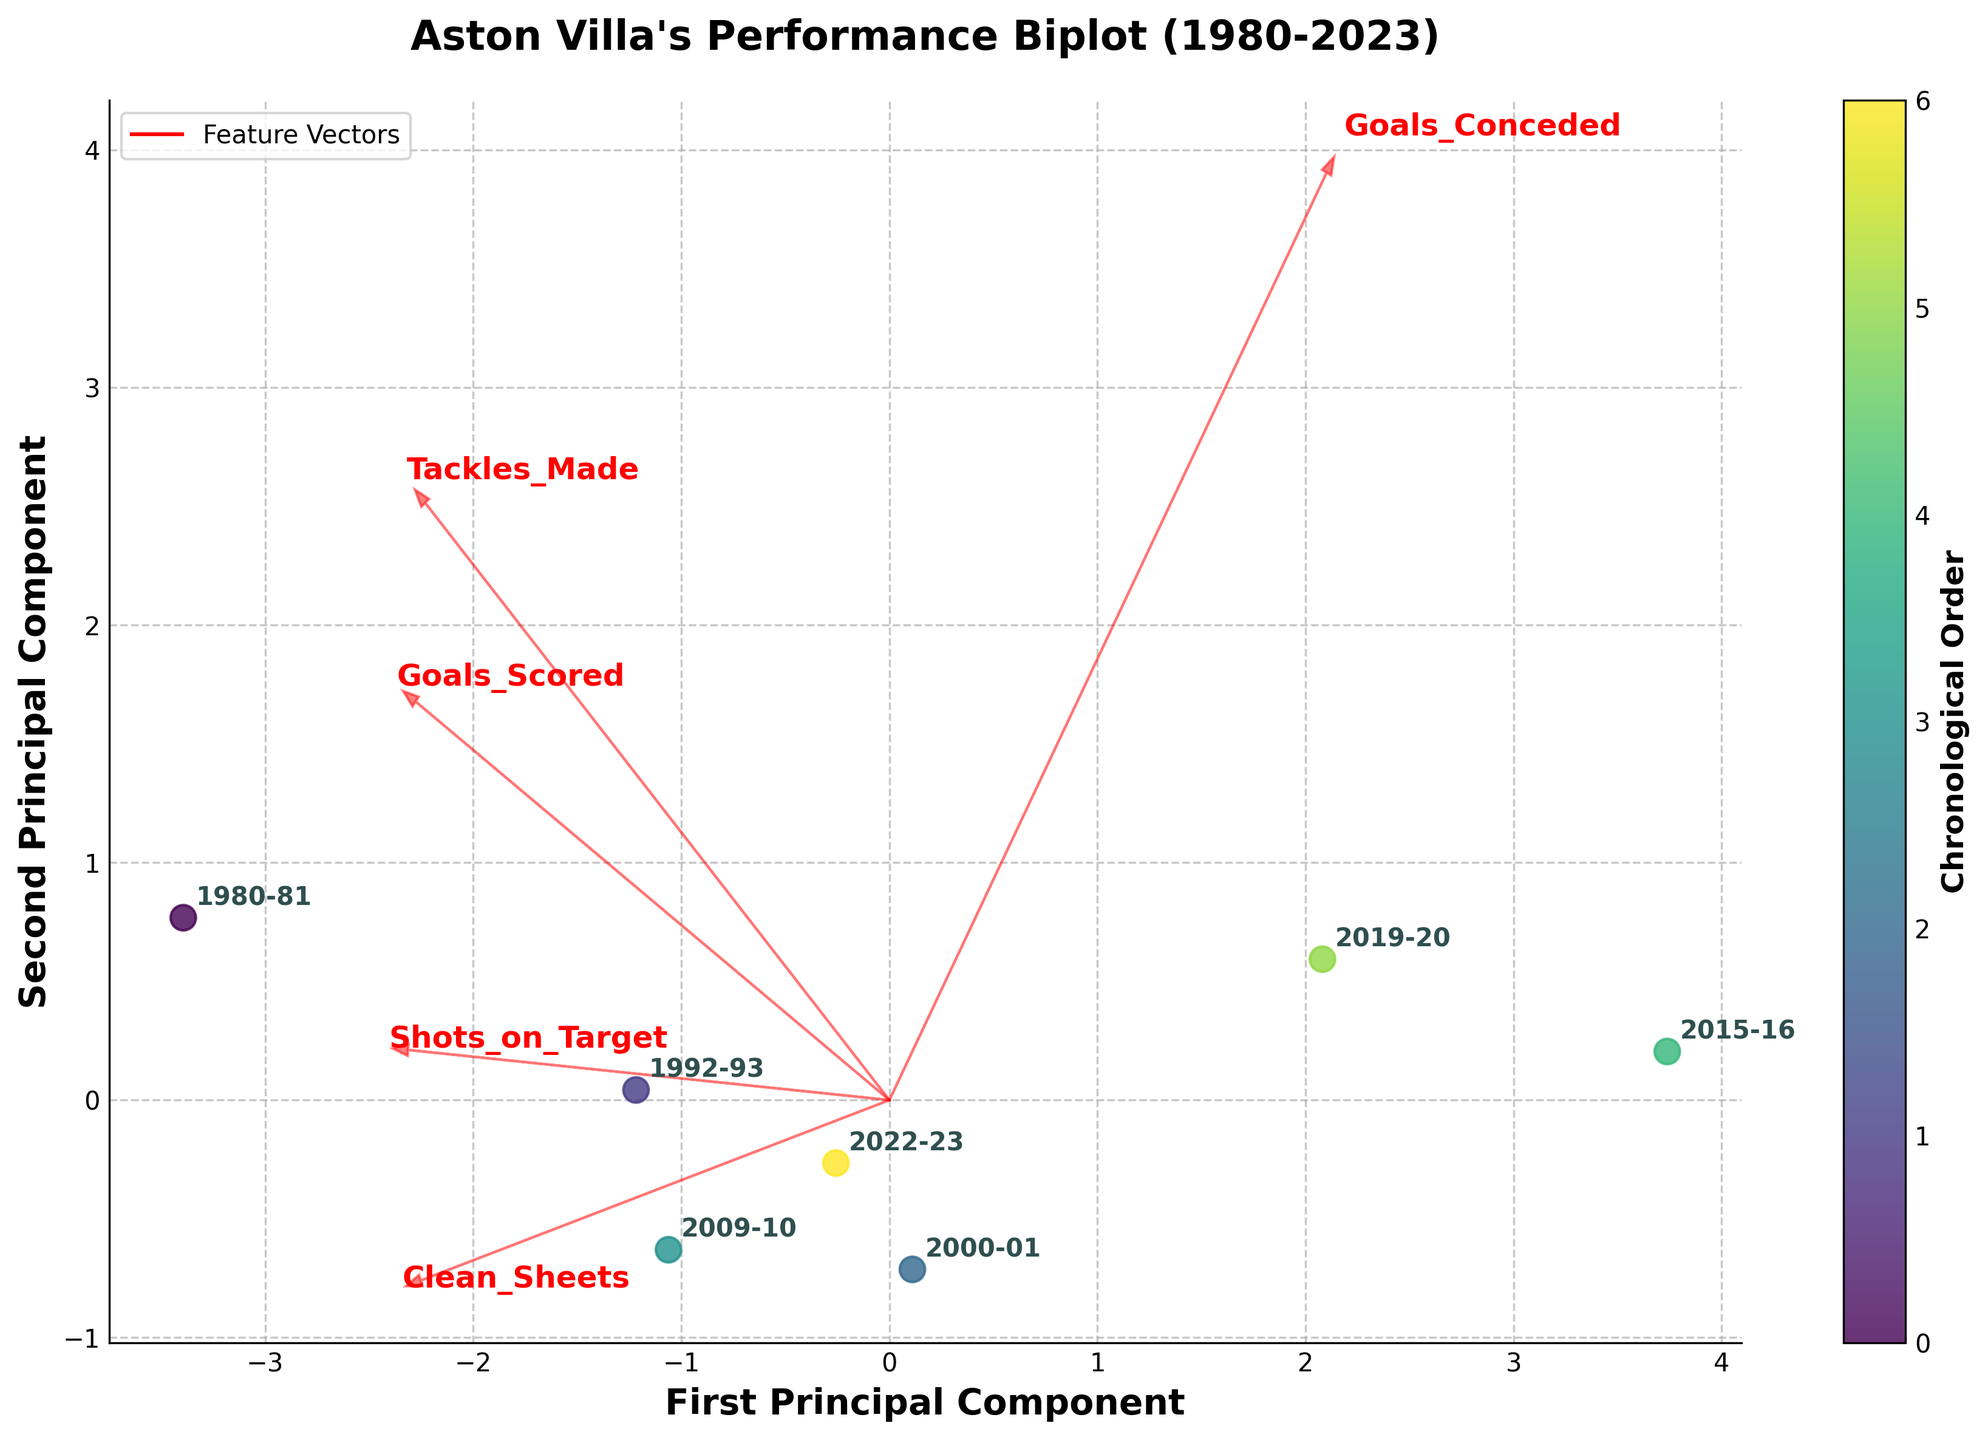What's the title of the figure? The title is usually prominently displayed at the top of the figure. Here, it reads "Aston Villa's Performance Biplot (1980-2023)."
Answer: Aston Villa's Performance Biplot (1980-2023) How many seasons are represented in the figure? Each point on the biplot represents a season, and there are 7 points labeled with seasons from 1980-2023.
Answer: 7 Which season experienced the highest goals conceded? The biplot shows a label for the 2015-16 season, which is located farthest in the direction of the 'Goals_Conceded' vector.
Answer: 2015-16 Which season has the highest overall performance based on the PCA plot? We interpret this by looking at the position of the points relative to both principal components. The 1980-81 season is positioned farthest from the origin in the positive direction, suggesting the highest performance.
Answer: 1980-81 How do seasons with many clean sheets compare in the plot? Seasons with many clean sheets (like 1980-81 and 2009-10) are located closer along the 'Clean_Sheets' vector. By comparing positions, these seasons cluster together.
Answer: 1980-81, 2009-10 Which feature vector is the longest, indicating the most variance explained by that feature? The length of arrows in a biplot represents the variance; in this case, 'Goals_Conceded' has the longest arrow, indicating it has the most variance.
Answer: Goals_Conceded What is the relationship between Goals Scored and Shots on Target? By looking at the vectors' directions, 'Goals_Scored' and 'Shots_on_Target' point in a similar direction, indicating a positive correlation.
Answer: Positive correlation How does the 2015-16 season's performance contrast with the 1980-81 season? The 2015-16 season is positioned near the 'Goals_Conceded' vector showing poor defensive performance, while the 1980-81 season is farther from this vector and closer to high 'Goals_Scored' and 'Clean_Sheets'.
Answer: 1980-81: Better offensive and defensive performance; 2015-16: Poor defensive performance Between the first and second principal components, which feature vectors are more aligned with the first principal component? Vectors like 'Goals_Conceded' and 'Goals_Scored' are more aligned with the first principal component since they point closer to its axis.
Answer: Goals_Conceded and Goals_Scored 